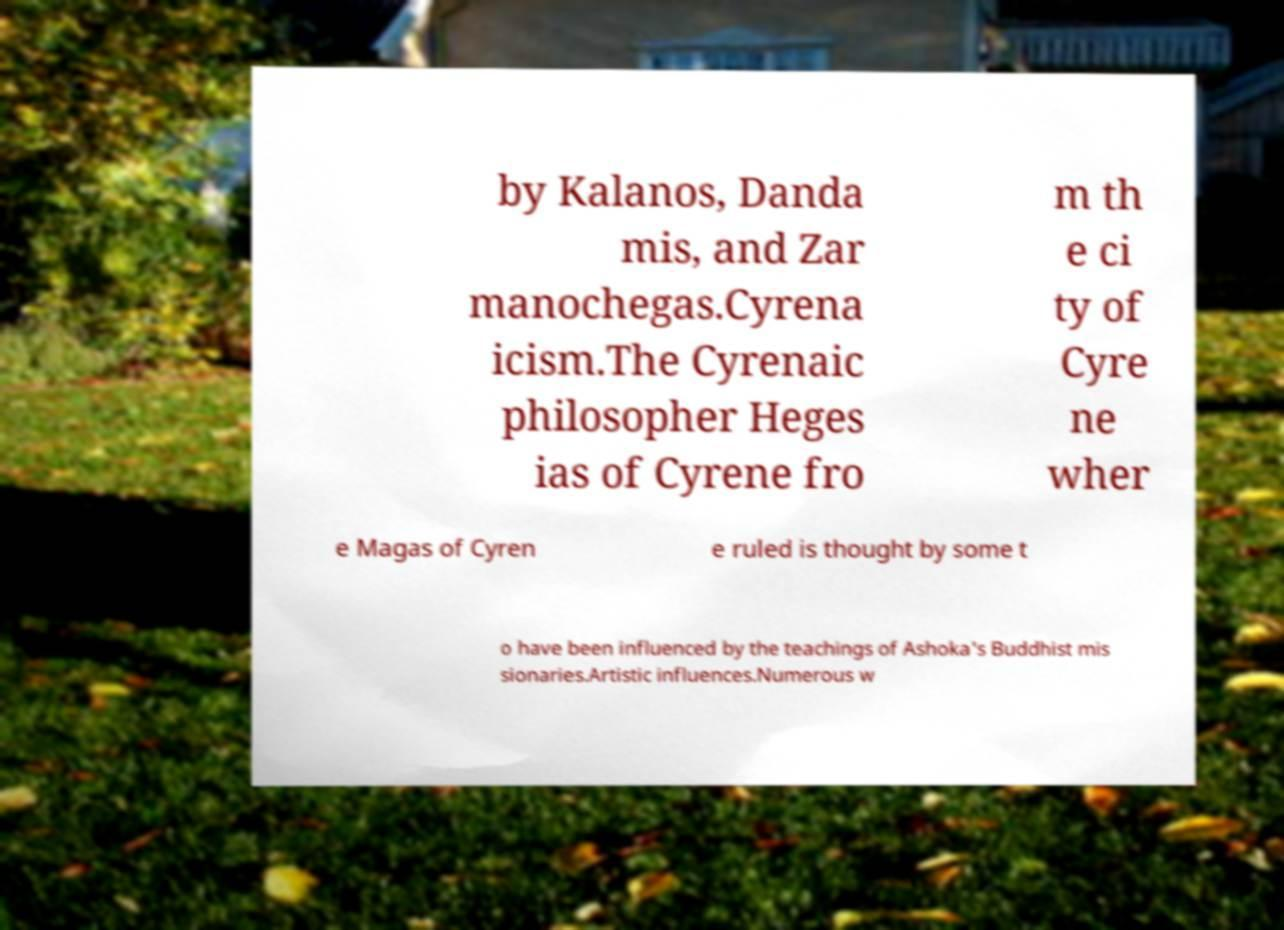Can you read and provide the text displayed in the image?This photo seems to have some interesting text. Can you extract and type it out for me? by Kalanos, Danda mis, and Zar manochegas.Cyrena icism.The Cyrenaic philosopher Heges ias of Cyrene fro m th e ci ty of Cyre ne wher e Magas of Cyren e ruled is thought by some t o have been influenced by the teachings of Ashoka's Buddhist mis sionaries.Artistic influences.Numerous w 